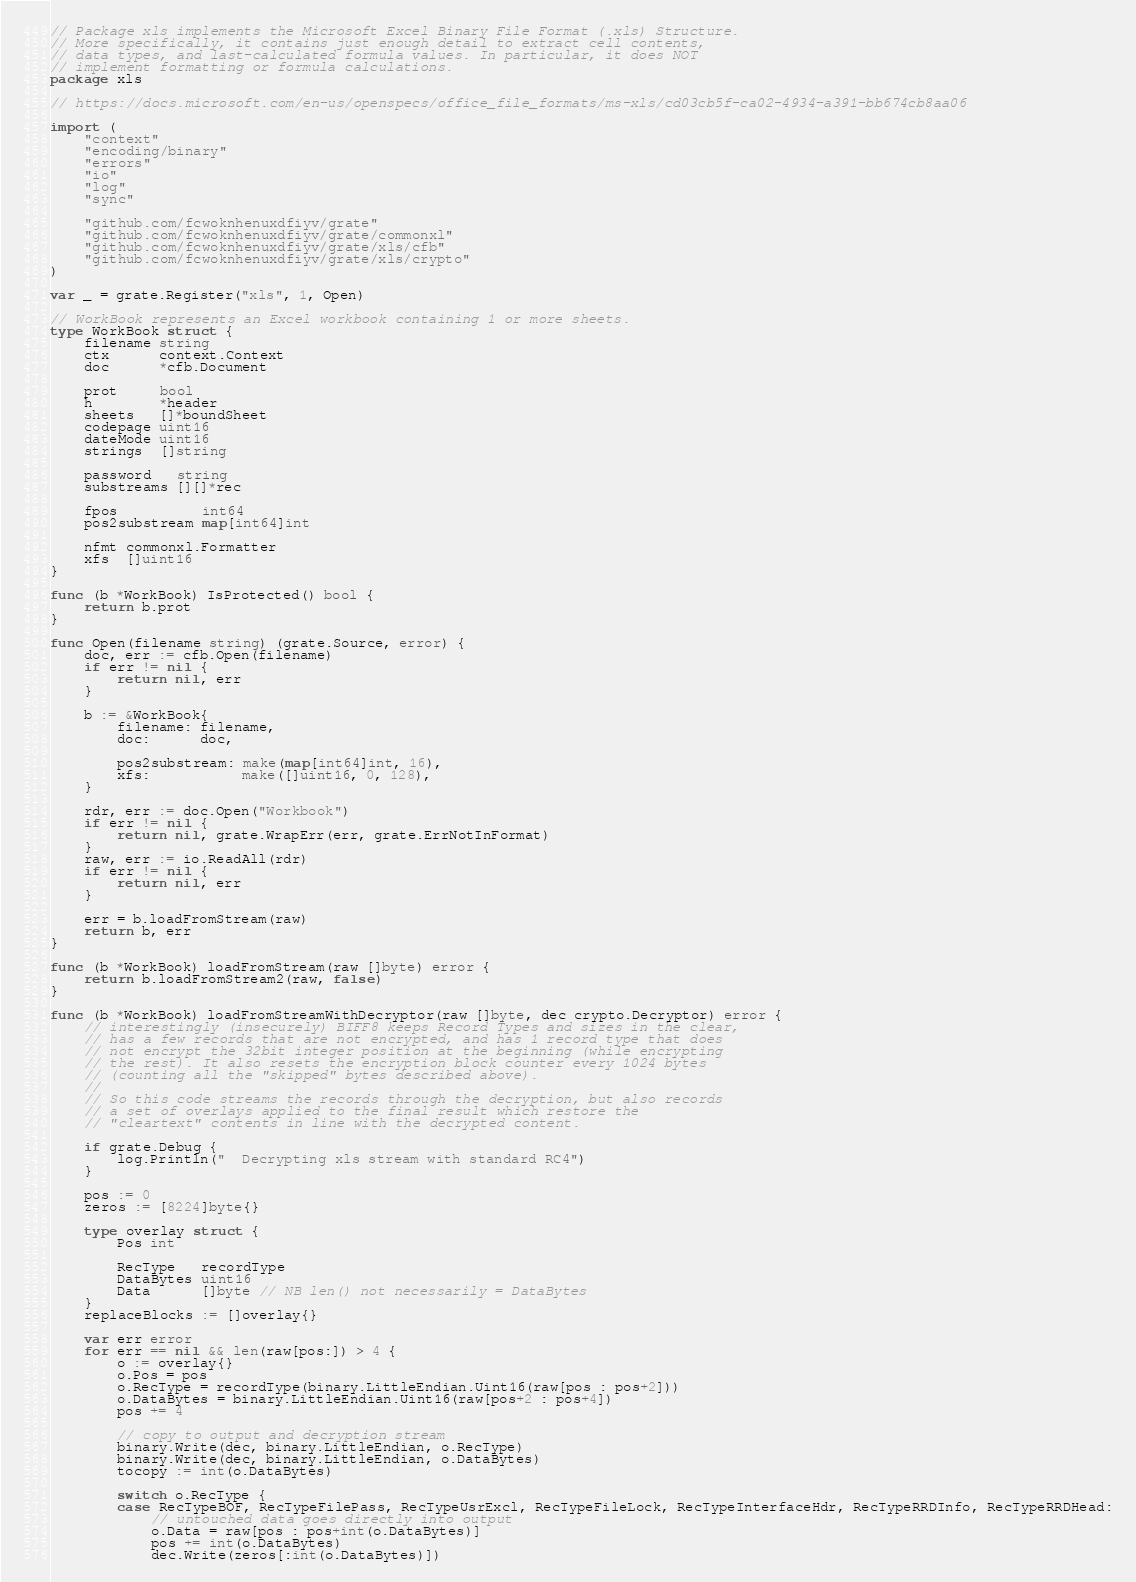Convert code to text. <code><loc_0><loc_0><loc_500><loc_500><_Go_>// Package xls implements the Microsoft Excel Binary File Format (.xls) Structure.
// More specifically, it contains just enough detail to extract cell contents,
// data types, and last-calculated formula values. In particular, it does NOT
// implement formatting or formula calculations.
package xls

// https://docs.microsoft.com/en-us/openspecs/office_file_formats/ms-xls/cd03cb5f-ca02-4934-a391-bb674cb8aa06

import (
	"context"
	"encoding/binary"
	"errors"
	"io"
	"log"
	"sync"

	"github.com/fcwoknhenuxdfiyv/grate"
	"github.com/fcwoknhenuxdfiyv/grate/commonxl"
	"github.com/fcwoknhenuxdfiyv/grate/xls/cfb"
	"github.com/fcwoknhenuxdfiyv/grate/xls/crypto"
)

var _ = grate.Register("xls", 1, Open)

// WorkBook represents an Excel workbook containing 1 or more sheets.
type WorkBook struct {
	filename string
	ctx      context.Context
	doc      *cfb.Document

	prot     bool
	h        *header
	sheets   []*boundSheet
	codepage uint16
	dateMode uint16
	strings  []string

	password   string
	substreams [][]*rec

	fpos          int64
	pos2substream map[int64]int

	nfmt commonxl.Formatter
	xfs  []uint16
}

func (b *WorkBook) IsProtected() bool {
	return b.prot
}

func Open(filename string) (grate.Source, error) {
	doc, err := cfb.Open(filename)
	if err != nil {
		return nil, err
	}

	b := &WorkBook{
		filename: filename,
		doc:      doc,

		pos2substream: make(map[int64]int, 16),
		xfs:           make([]uint16, 0, 128),
	}

	rdr, err := doc.Open("Workbook")
	if err != nil {
		return nil, grate.WrapErr(err, grate.ErrNotInFormat)
	}
	raw, err := io.ReadAll(rdr)
	if err != nil {
		return nil, err
	}

	err = b.loadFromStream(raw)
	return b, err
}

func (b *WorkBook) loadFromStream(raw []byte) error {
	return b.loadFromStream2(raw, false)
}

func (b *WorkBook) loadFromStreamWithDecryptor(raw []byte, dec crypto.Decryptor) error {
	// interestingly (insecurely) BIFF8 keeps Record Types and sizes in the clear,
	// has a few records that are not encrypted, and has 1 record type that does
	// not encrypt the 32bit integer position at the beginning (while encrypting
	// the rest). It also resets the encryption block counter every 1024 bytes
	// (counting all the "skipped" bytes described above).
	//
	// So this code streams the records through the decryption, but also records
	// a set of overlays applied to the final result which restore the
	// "cleartext" contents in line with the decrypted content.

	if grate.Debug {
		log.Println("  Decrypting xls stream with standard RC4")
	}

	pos := 0
	zeros := [8224]byte{}

	type overlay struct {
		Pos int

		RecType   recordType
		DataBytes uint16
		Data      []byte // NB len() not necessarily = DataBytes
	}
	replaceBlocks := []overlay{}

	var err error
	for err == nil && len(raw[pos:]) > 4 {
		o := overlay{}
		o.Pos = pos
		o.RecType = recordType(binary.LittleEndian.Uint16(raw[pos : pos+2]))
		o.DataBytes = binary.LittleEndian.Uint16(raw[pos+2 : pos+4])
		pos += 4

		// copy to output and decryption stream
		binary.Write(dec, binary.LittleEndian, o.RecType)
		binary.Write(dec, binary.LittleEndian, o.DataBytes)
		tocopy := int(o.DataBytes)

		switch o.RecType {
		case RecTypeBOF, RecTypeFilePass, RecTypeUsrExcl, RecTypeFileLock, RecTypeInterfaceHdr, RecTypeRRDInfo, RecTypeRRDHead:
			// untouched data goes directly into output
			o.Data = raw[pos : pos+int(o.DataBytes)]
			pos += int(o.DataBytes)
			dec.Write(zeros[:int(o.DataBytes)])</code> 